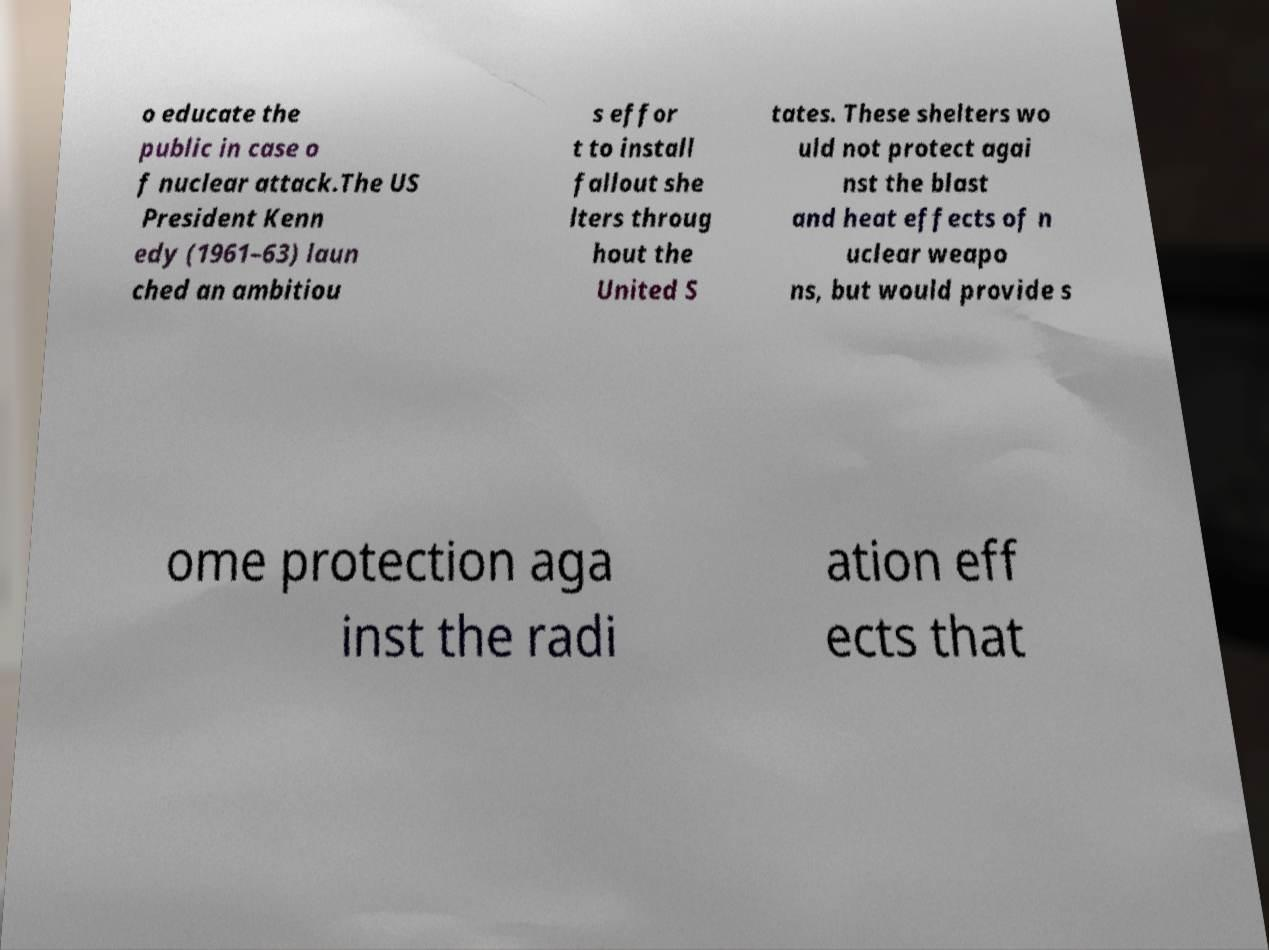Could you extract and type out the text from this image? o educate the public in case o f nuclear attack.The US President Kenn edy (1961–63) laun ched an ambitiou s effor t to install fallout she lters throug hout the United S tates. These shelters wo uld not protect agai nst the blast and heat effects of n uclear weapo ns, but would provide s ome protection aga inst the radi ation eff ects that 